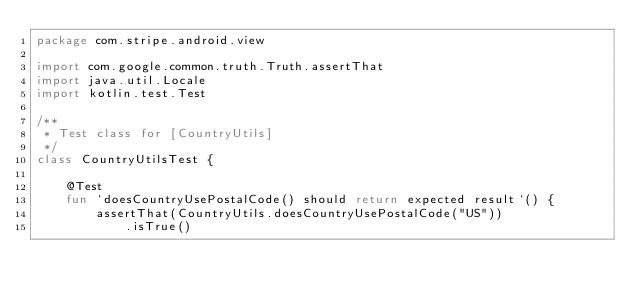Convert code to text. <code><loc_0><loc_0><loc_500><loc_500><_Kotlin_>package com.stripe.android.view

import com.google.common.truth.Truth.assertThat
import java.util.Locale
import kotlin.test.Test

/**
 * Test class for [CountryUtils]
 */
class CountryUtilsTest {

    @Test
    fun `doesCountryUsePostalCode() should return expected result`() {
        assertThat(CountryUtils.doesCountryUsePostalCode("US"))
            .isTrue()</code> 